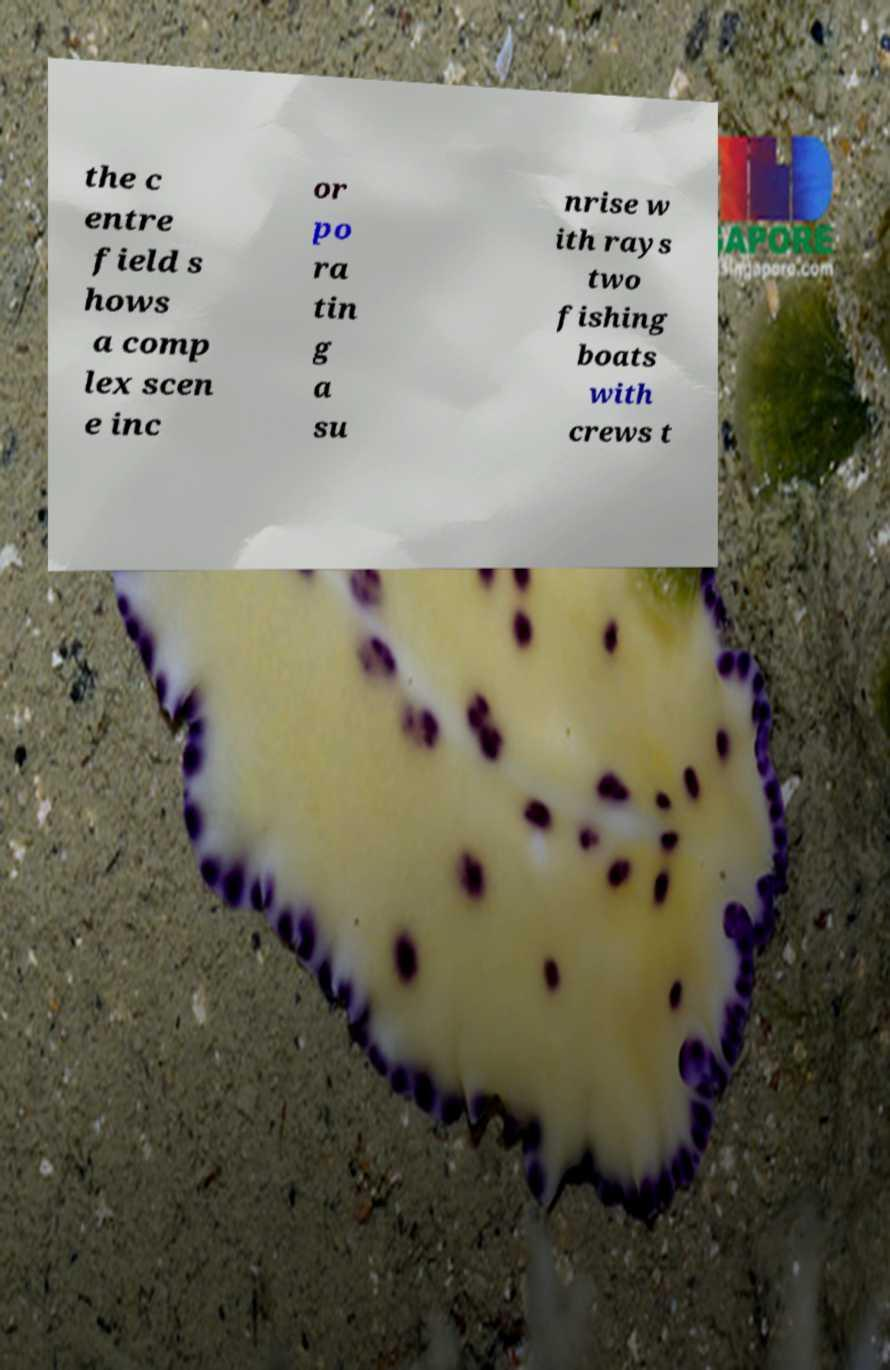Please read and relay the text visible in this image. What does it say? the c entre field s hows a comp lex scen e inc or po ra tin g a su nrise w ith rays two fishing boats with crews t 